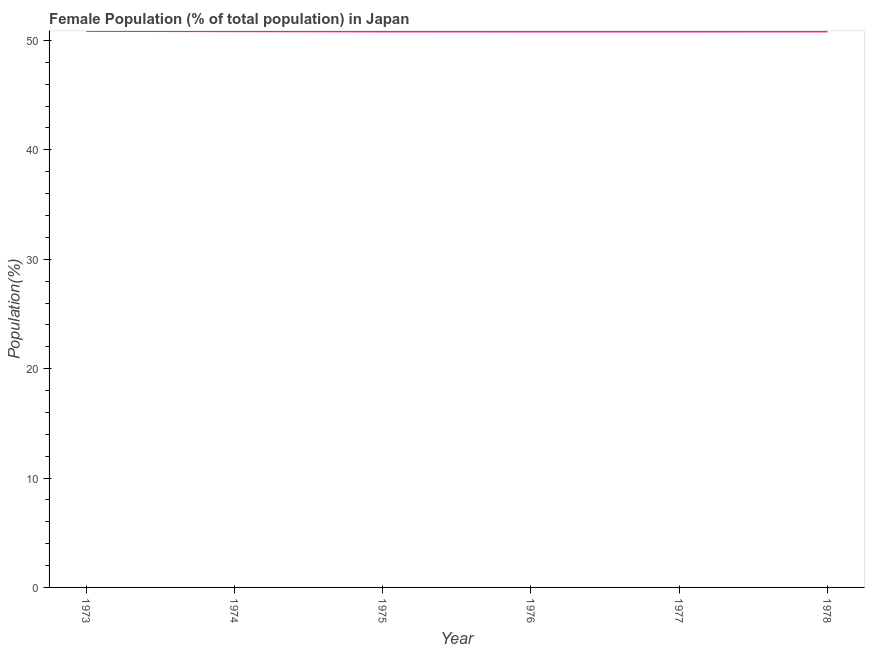What is the female population in 1976?
Ensure brevity in your answer.  50.82. Across all years, what is the maximum female population?
Your answer should be compact. 50.88. Across all years, what is the minimum female population?
Offer a very short reply. 50.82. In which year was the female population maximum?
Keep it short and to the point. 1973. In which year was the female population minimum?
Your answer should be very brief. 1976. What is the sum of the female population?
Give a very brief answer. 305.02. What is the difference between the female population in 1976 and 1977?
Offer a terse response. -0. What is the average female population per year?
Give a very brief answer. 50.84. What is the median female population?
Give a very brief answer. 50.83. In how many years, is the female population greater than 6 %?
Your answer should be very brief. 6. What is the ratio of the female population in 1974 to that in 1977?
Ensure brevity in your answer.  1. What is the difference between the highest and the second highest female population?
Make the answer very short. 0.03. Is the sum of the female population in 1975 and 1977 greater than the maximum female population across all years?
Your answer should be compact. Yes. What is the difference between the highest and the lowest female population?
Ensure brevity in your answer.  0.06. In how many years, is the female population greater than the average female population taken over all years?
Make the answer very short. 2. Does the graph contain any zero values?
Ensure brevity in your answer.  No. Does the graph contain grids?
Your response must be concise. No. What is the title of the graph?
Ensure brevity in your answer.  Female Population (% of total population) in Japan. What is the label or title of the Y-axis?
Provide a succinct answer. Population(%). What is the Population(%) of 1973?
Offer a terse response. 50.88. What is the Population(%) in 1974?
Ensure brevity in your answer.  50.85. What is the Population(%) of 1975?
Ensure brevity in your answer.  50.83. What is the Population(%) in 1976?
Your answer should be compact. 50.82. What is the Population(%) in 1977?
Provide a succinct answer. 50.82. What is the Population(%) of 1978?
Provide a short and direct response. 50.83. What is the difference between the Population(%) in 1973 and 1974?
Give a very brief answer. 0.03. What is the difference between the Population(%) in 1973 and 1975?
Your answer should be compact. 0.05. What is the difference between the Population(%) in 1973 and 1976?
Your answer should be very brief. 0.06. What is the difference between the Population(%) in 1973 and 1977?
Your answer should be very brief. 0.06. What is the difference between the Population(%) in 1973 and 1978?
Provide a short and direct response. 0.05. What is the difference between the Population(%) in 1974 and 1975?
Provide a succinct answer. 0.02. What is the difference between the Population(%) in 1974 and 1976?
Your response must be concise. 0.03. What is the difference between the Population(%) in 1974 and 1977?
Your answer should be compact. 0.03. What is the difference between the Population(%) in 1974 and 1978?
Ensure brevity in your answer.  0.02. What is the difference between the Population(%) in 1975 and 1976?
Offer a terse response. 0.01. What is the difference between the Population(%) in 1975 and 1977?
Your answer should be compact. 0.01. What is the difference between the Population(%) in 1975 and 1978?
Ensure brevity in your answer.  0. What is the difference between the Population(%) in 1976 and 1977?
Keep it short and to the point. -0. What is the difference between the Population(%) in 1976 and 1978?
Provide a short and direct response. -0.01. What is the difference between the Population(%) in 1977 and 1978?
Your response must be concise. -0.01. What is the ratio of the Population(%) in 1974 to that in 1975?
Provide a short and direct response. 1. What is the ratio of the Population(%) in 1974 to that in 1976?
Your answer should be very brief. 1. What is the ratio of the Population(%) in 1974 to that in 1978?
Your response must be concise. 1. What is the ratio of the Population(%) in 1975 to that in 1976?
Give a very brief answer. 1. What is the ratio of the Population(%) in 1975 to that in 1978?
Offer a terse response. 1. What is the ratio of the Population(%) in 1976 to that in 1977?
Your answer should be very brief. 1. What is the ratio of the Population(%) in 1976 to that in 1978?
Provide a short and direct response. 1. What is the ratio of the Population(%) in 1977 to that in 1978?
Provide a short and direct response. 1. 